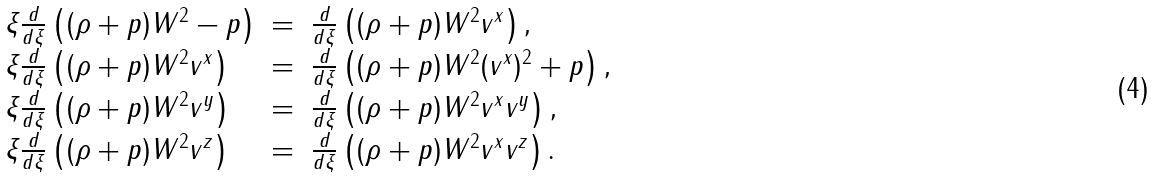Convert formula to latex. <formula><loc_0><loc_0><loc_500><loc_500>\begin{array} { l c l } \xi \frac { d } { d \xi } \left ( ( \rho + p ) W ^ { 2 } - p \right ) & = & \frac { d } { d \xi } \left ( ( \rho + p ) W ^ { 2 } v ^ { x } \right ) , \\ \xi \frac { d } { d \xi } \left ( ( \rho + p ) W ^ { 2 } v ^ { x } \right ) & = & \frac { d } { d \xi } \left ( ( \rho + p ) W ^ { 2 } ( v ^ { x } ) ^ { 2 } + p \right ) , \\ \xi \frac { d } { d \xi } \left ( ( \rho + p ) W ^ { 2 } v ^ { y } \right ) & = & \frac { d } { d \xi } \left ( ( \rho + p ) W ^ { 2 } v ^ { x } v ^ { y } \right ) , \\ \xi \frac { d } { d \xi } \left ( ( \rho + p ) W ^ { 2 } v ^ { z } \right ) & = & \frac { d } { d \xi } \left ( ( \rho + p ) W ^ { 2 } v ^ { x } v ^ { z } \right ) . \end{array}</formula> 